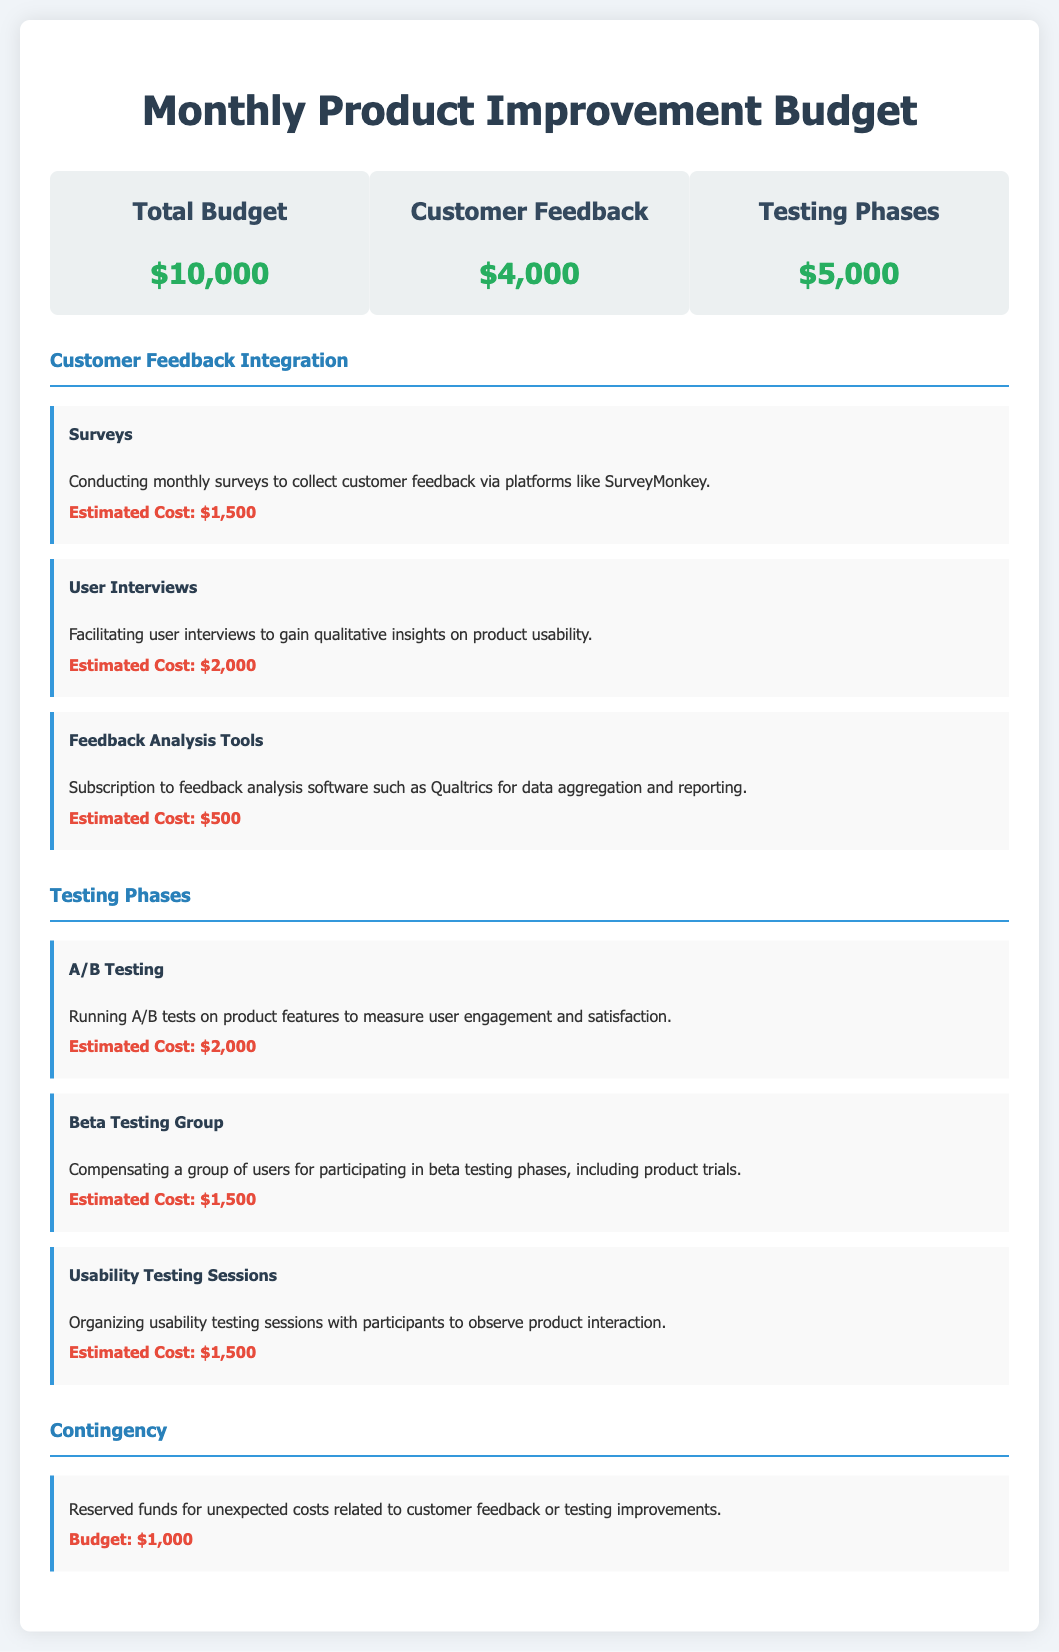What is the total budget? The total budget is presented in the overview section of the document as $10,000.
Answer: $10,000 How much is allocated for customer feedback? The allocation for customer feedback is clearly shown in the budget overview, totaling $4,000.
Answer: $4,000 What is the estimated cost for surveys? The estimated cost for surveys is specified under customer feedback integration as $1,500.
Answer: $1,500 What type of testing is listed with an estimated cost of $2,000? A/B Testing is mentioned in the testing phases with an estimated cost of $2,000.
Answer: A/B Testing What is the budget for contingency? The document indicates a reserved budget for contingency, which is $1,000.
Answer: $1,000 Which feedback analysis tool is mentioned? The document mentions the use of Qualtrics as a feedback analysis tool.
Answer: Qualtrics What is the total estimated cost allocated for usability testing sessions? The total estimated cost for usability testing sessions is provided as $1,500, which is detailed in the testing phases section.
Answer: $1,500 Which customer feedback integration method has the highest cost? User Interviews have the highest estimated cost of $2,000 listed under customer feedback integration.
Answer: User Interviews What is the primary purpose of the beta testing group? The primary purpose of the beta testing group is for product trials as indicated in the document.
Answer: Product trials 